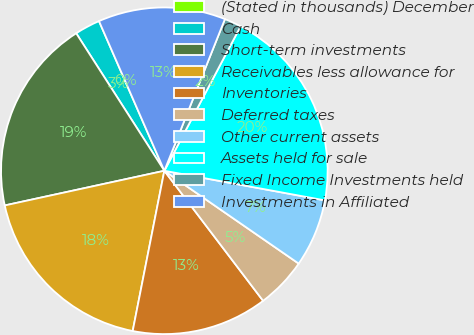Convert chart. <chart><loc_0><loc_0><loc_500><loc_500><pie_chart><fcel>(Stated in thousands) December<fcel>Cash<fcel>Short-term investments<fcel>Receivables less allowance for<fcel>Inventories<fcel>Deferred taxes<fcel>Other current assets<fcel>Assets held for sale<fcel>Fixed Income Investments held<fcel>Investments in Affiliated<nl><fcel>0.0%<fcel>2.52%<fcel>19.33%<fcel>18.49%<fcel>13.44%<fcel>5.04%<fcel>6.72%<fcel>20.17%<fcel>1.68%<fcel>12.6%<nl></chart> 